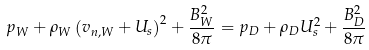Convert formula to latex. <formula><loc_0><loc_0><loc_500><loc_500>p _ { W } + \rho _ { W } \left ( v _ { n , W } + U _ { s } \right ) ^ { 2 } + \frac { B _ { W } ^ { 2 } } { 8 \pi } = p _ { D } + \rho _ { D } U _ { s } ^ { 2 } + \frac { B _ { D } ^ { 2 } } { 8 \pi }</formula> 